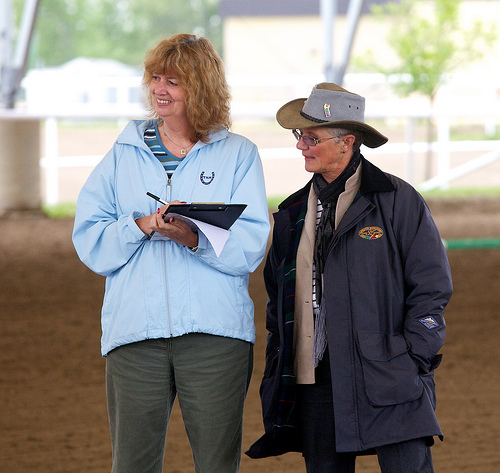<image>
Is the scarf on the woman? No. The scarf is not positioned on the woman. They may be near each other, but the scarf is not supported by or resting on top of the woman. Is the clipboard on the man? No. The clipboard is not positioned on the man. They may be near each other, but the clipboard is not supported by or resting on top of the man. Is the man next to the women? Yes. The man is positioned adjacent to the women, located nearby in the same general area. 